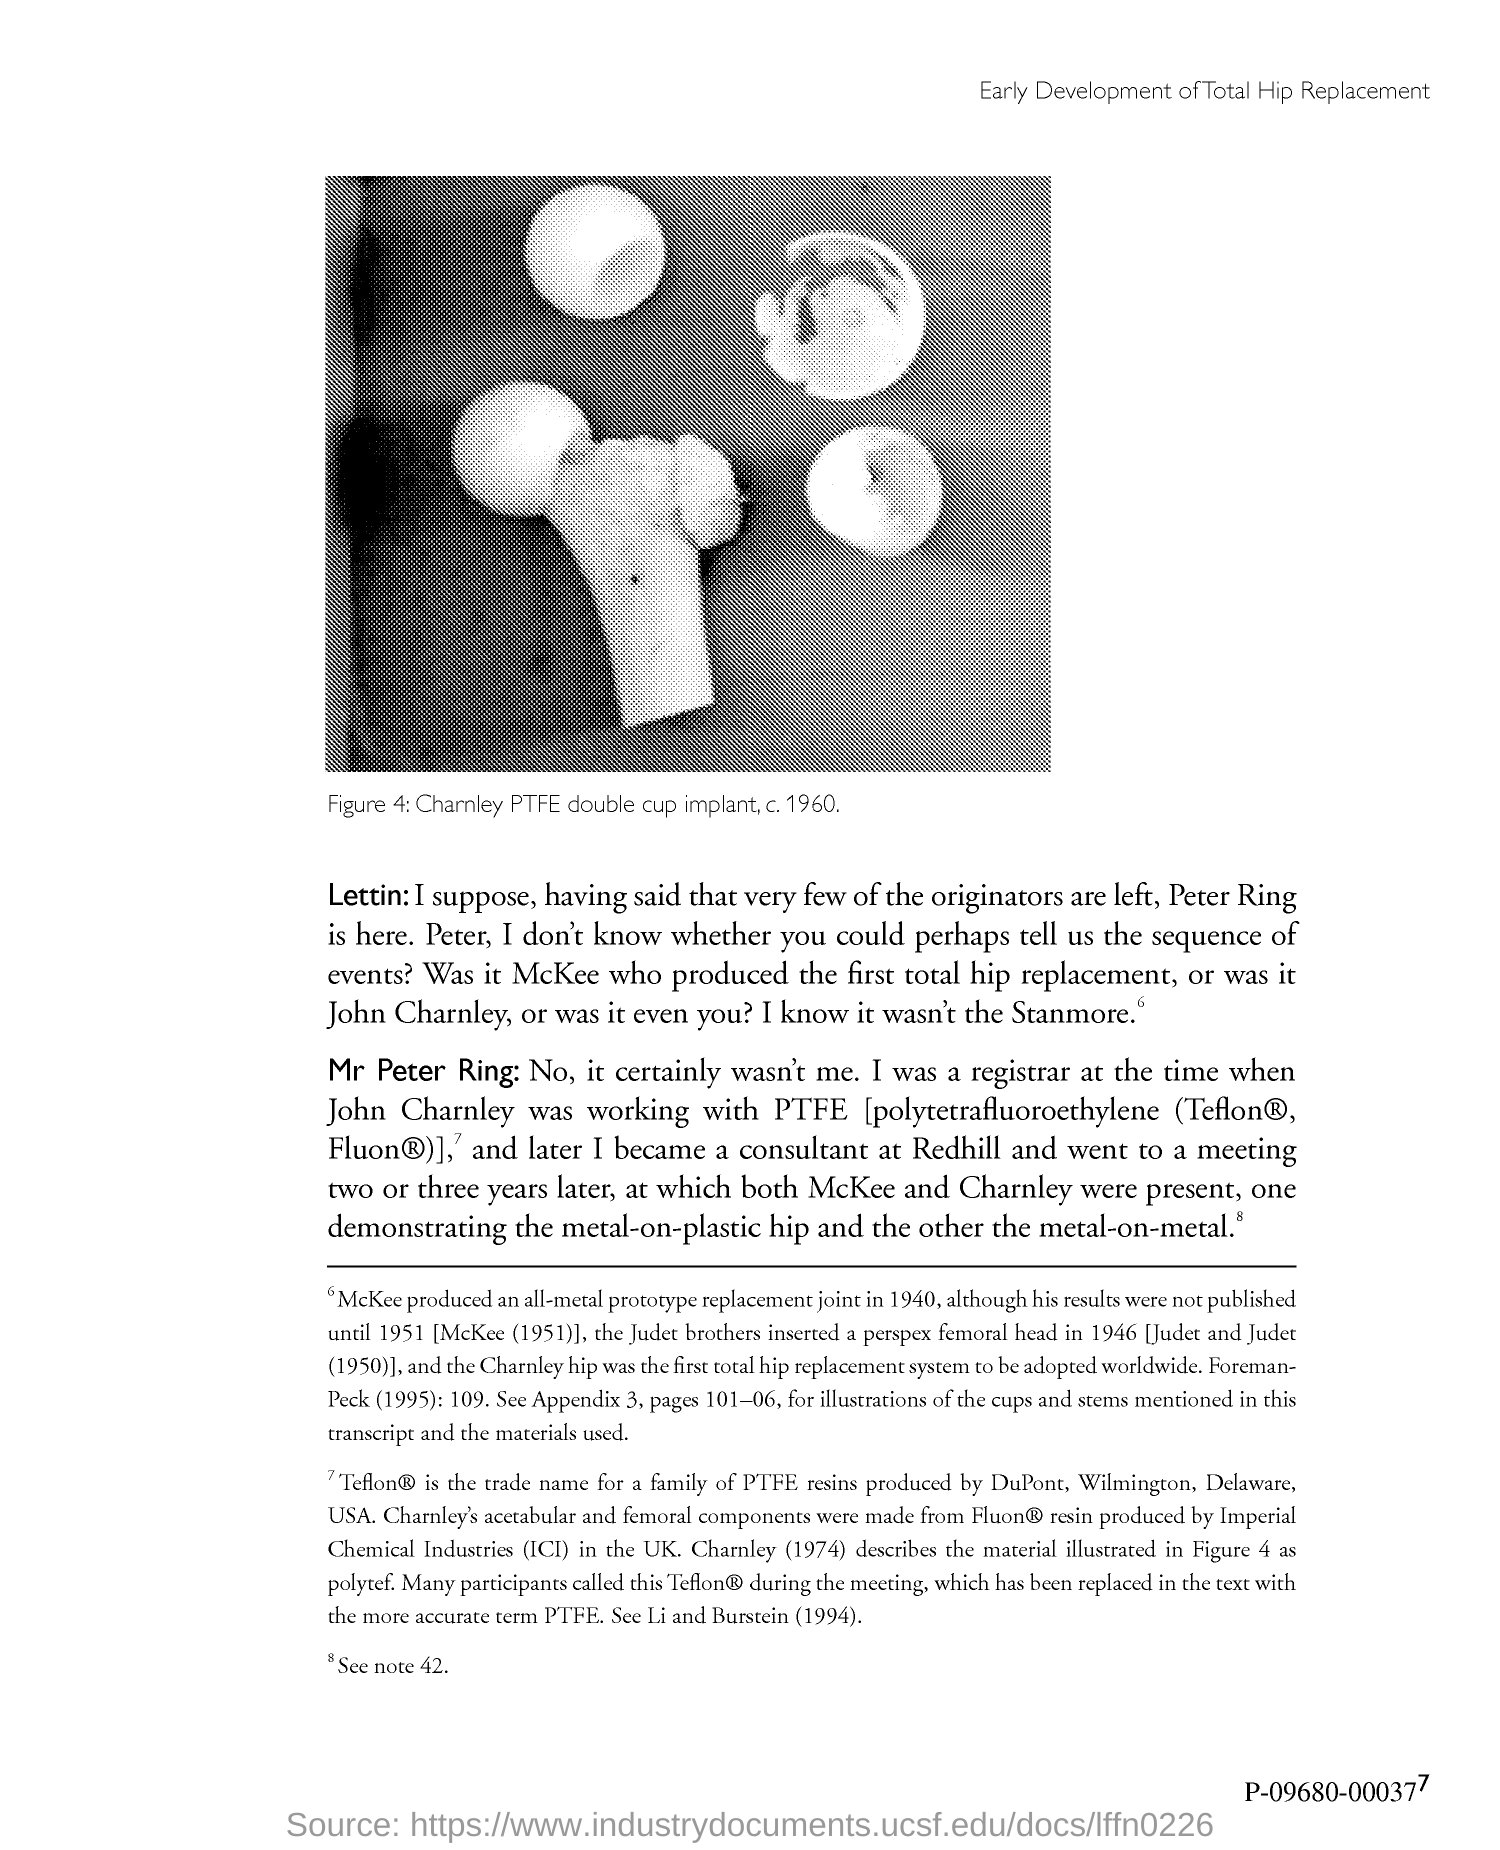Point out several critical features in this image. In 1940, McKee produced an all-metal prototype replacement joint. 